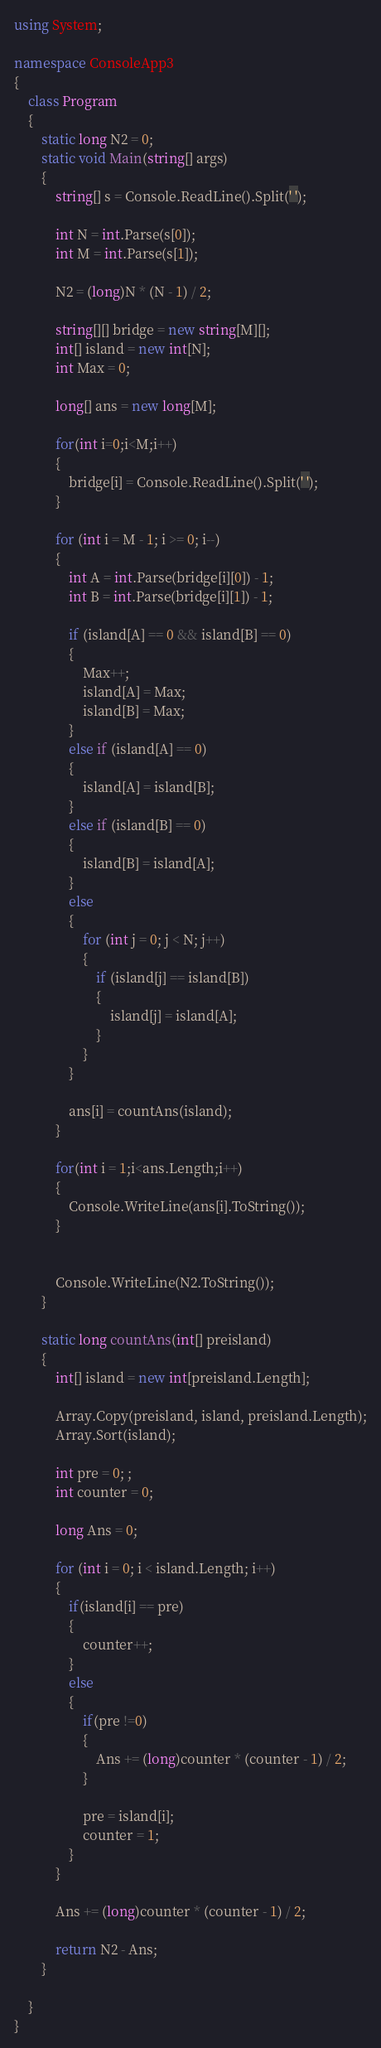Convert code to text. <code><loc_0><loc_0><loc_500><loc_500><_C#_>using System;

namespace ConsoleApp3
{
    class Program
    {
        static long N2 = 0;
        static void Main(string[] args)
        {
            string[] s = Console.ReadLine().Split(' ');

            int N = int.Parse(s[0]);
            int M = int.Parse(s[1]);

            N2 = (long)N * (N - 1) / 2;

            string[][] bridge = new string[M][];
            int[] island = new int[N];
            int Max = 0;

            long[] ans = new long[M];

            for(int i=0;i<M;i++)
            {
                bridge[i] = Console.ReadLine().Split(' ');
            }

            for (int i = M - 1; i >= 0; i--)
            {
                int A = int.Parse(bridge[i][0]) - 1;
                int B = int.Parse(bridge[i][1]) - 1;

                if (island[A] == 0 && island[B] == 0)
                {
                    Max++;
                    island[A] = Max;
                    island[B] = Max;
                }
                else if (island[A] == 0)
                {
                    island[A] = island[B];
                }
                else if (island[B] == 0)
                {
                    island[B] = island[A];
                }
                else
                {
                    for (int j = 0; j < N; j++)
                    {
                        if (island[j] == island[B])
                        {
                            island[j] = island[A];
                        }
                    }
                }

                ans[i] = countAns(island);
            }

            for(int i = 1;i<ans.Length;i++)
            {
                Console.WriteLine(ans[i].ToString());
            }


            Console.WriteLine(N2.ToString());
        }

        static long countAns(int[] preisland)
        {
            int[] island = new int[preisland.Length];

            Array.Copy(preisland, island, preisland.Length);
            Array.Sort(island);

            int pre = 0; ;
            int counter = 0;

            long Ans = 0;

            for (int i = 0; i < island.Length; i++)
            {
                if(island[i] == pre)
                {
                    counter++;
                }
                else
                {
                    if(pre !=0)
                    {
                        Ans += (long)counter * (counter - 1) / 2;
                    }

                    pre = island[i];
                    counter = 1;
                }
            }

            Ans += (long)counter * (counter - 1) / 2;

            return N2 - Ans;
        }

    }
}
</code> 